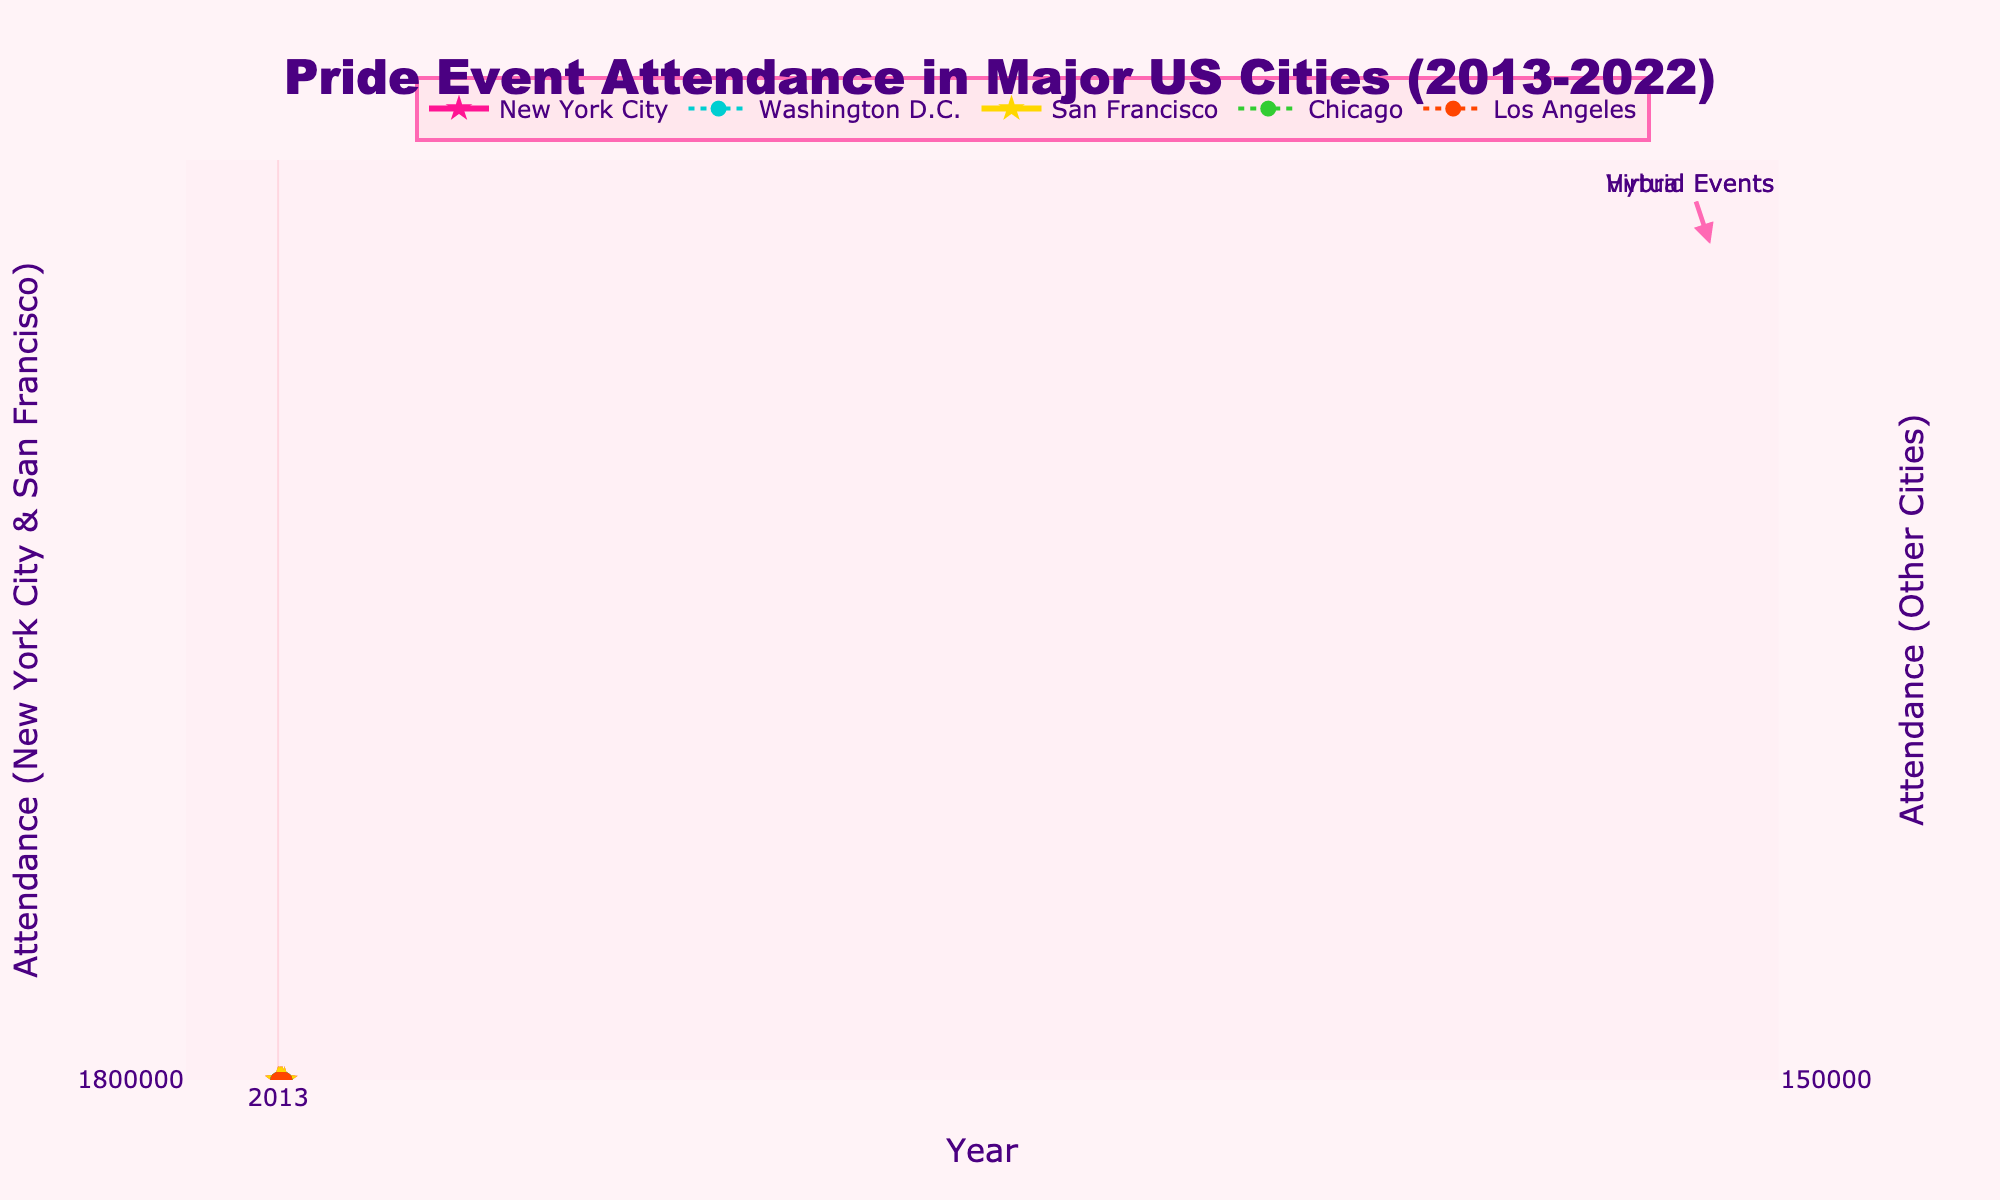what is the overall trend in attendance for New York City from 2013 to 2022? The attendance in New York City consistently increased from 2013 (1,800,000) to 2019 (5,000,000). There was a dip in 2022 to 2,800,000.
Answer: Increasing, then decreasing how did the attendance in Washington D.C. in 2019 compare to 2022? Attendance increased from 400,000 in 2019 to 500,000 in 2022.
Answer: Increased which city had the highest attendance in 2015? In 2015, New York City had the highest attendance with 2,200,000 attendees.
Answer: New York City what is the average attendance in Chicago from 2013-2019 (excluding virtual and hybrid years)? Add the attendance numbers for Chicago from 2013-2019: 850,000 + 900,000 + 950,000 + 1,000,000 + 1,100,000 + 1,200,000 + 1,300,000 = 7,300,000. There are 7 data points. 7,300,000 /7 = 1,042,857
Answer: 1,042,857 how many years did San Francisco have a decreasing attendance trend? Between 2013 to 2022, San Francisco attendance increased every year except for the dip in 2022 after the hybrid period.
Answer: 1 year what are the distinct attendance characteristics of virtual and hybrid events? Virtual events occurred in 2020 with no physical attendance data. Hybrid events occurred in 2021 with also no distinct physical attendance data represented.
Answer: No physical attendance data which city saw the largest increase in attendance from 2013 to 2016? New York City had an increase from 1,800,000 to 2,500,000, which is an increase of 700,000.
Answer: New York City what was the attendance difference between San Francisco and Los Angeles in 2018? In 2018, San Francisco had 1,700,000 attendees and Los Angeles had 650,000. So the difference is 1,700,000 - 650,000 = 1,050,000.
Answer: 1,050,000 did any city experience a peak in attendance in 2019? Yes, New York City peaked with 5,000,000 attendees.
Answer: Yes 